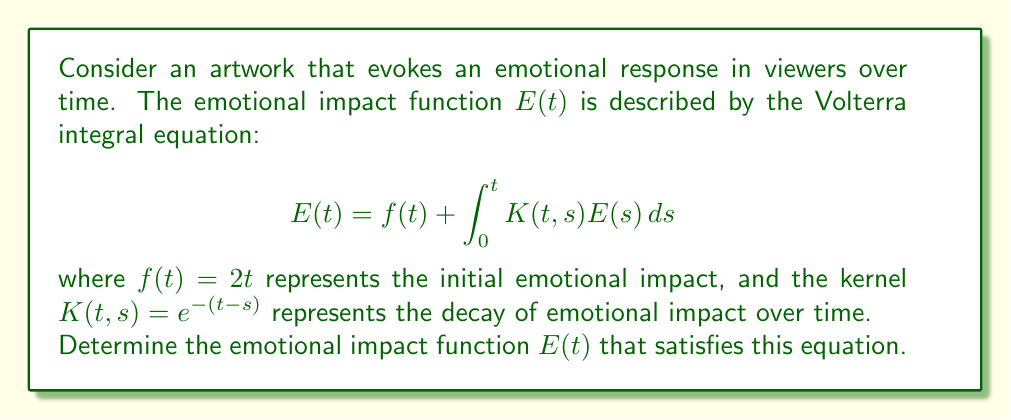Could you help me with this problem? To solve this Volterra integral equation, we'll use the method of successive approximations:

1) Start with the initial approximation $E_0(t) = f(t) = 2t$

2) Use the recurrence relation:
   $$E_{n+1}(t) = f(t) + \int_0^t K(t,s)E_n(s)ds$$

3) Calculate $E_1(t)$:
   $$\begin{aligned}
   E_1(t) &= 2t + \int_0^t e^{-(t-s)}(2s)ds \\
   &= 2t + 2e^{-t}\int_0^t se^s ds \\
   &= 2t + 2e^{-t}(te^t - e^t + 1) \\
   &= 2t + 2t - 2 + 2e^{-t}
   \end{aligned}$$

4) Calculate $E_2(t)$:
   $$\begin{aligned}
   E_2(t) &= 2t + \int_0^t e^{-(t-s)}(4s - 2 + 2e^{-s})ds \\
   &= 2t + 4e^{-t}\int_0^t se^s ds - 2\int_0^t e^{-(t-s)}ds + 2\int_0^t e^{-t}ds \\
   &= 2t + 4(t - 1 + e^{-t}) - 2(1 - e^{-t}) + 2te^{-t} \\
   &= 4t - 2 + 4e^{-t}
   \end{aligned}$$

5) We observe that $E_2(t) = E_1(t)$, which means we've reached the solution.

Therefore, the emotional impact function is:
$$E(t) = 4t - 2 + 4e^{-t}$$

This function represents how the emotional impact of the artwork changes over time, combining a linear growth term ($4t$), a constant offset ($-2$), and an exponential decay term ($4e^{-t}$).
Answer: $E(t) = 4t - 2 + 4e^{-t}$ 